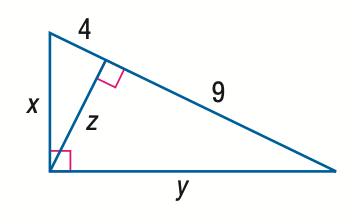Answer the mathemtical geometry problem and directly provide the correct option letter.
Question: Find z.
Choices: A: 4 B: 6 C: 9 D: 36 B 